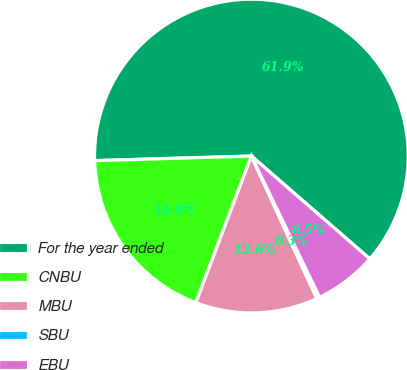<chart> <loc_0><loc_0><loc_500><loc_500><pie_chart><fcel>For the year ended<fcel>CNBU<fcel>MBU<fcel>SBU<fcel>EBU<nl><fcel>61.85%<fcel>18.77%<fcel>12.61%<fcel>0.31%<fcel>6.46%<nl></chart> 